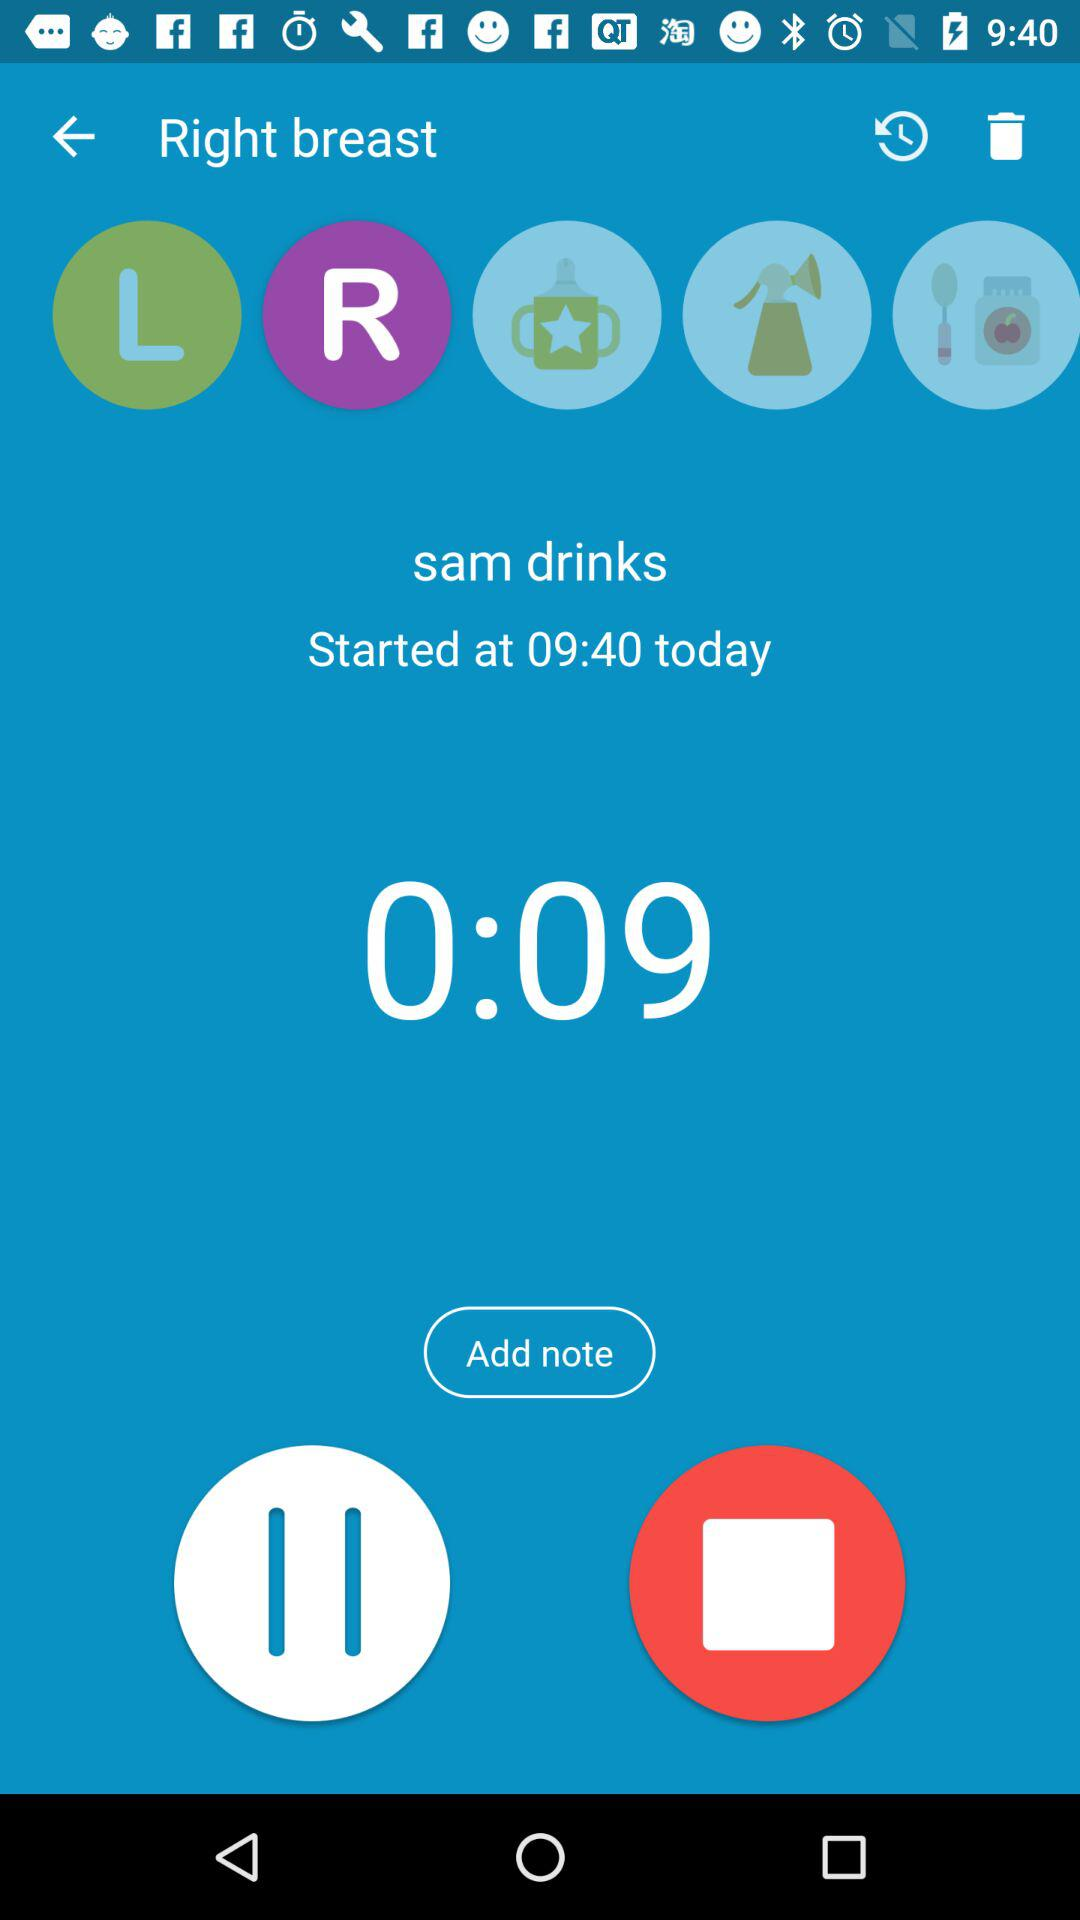How long has the feeding been going on for?
Answer the question using a single word or phrase. 0:09 